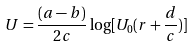Convert formula to latex. <formula><loc_0><loc_0><loc_500><loc_500>U = \frac { ( a - b ) } { 2 c } \log [ U _ { 0 } ( r + { \frac { d } { c } } ) ]</formula> 